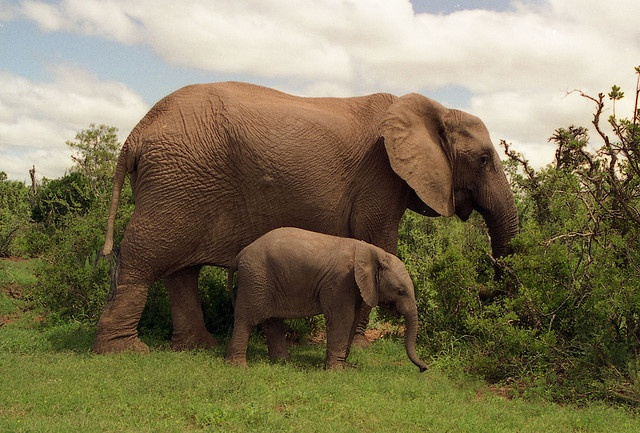Describe the objects in this image and their specific colors. I can see elephant in darkgray, black, maroon, and gray tones and elephant in darkgray, black, olive, and gray tones in this image. 